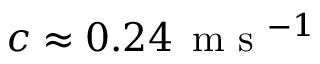<formula> <loc_0><loc_0><loc_500><loc_500>c \approx 0 . 2 4 \, m s ^ { - 1 }</formula> 